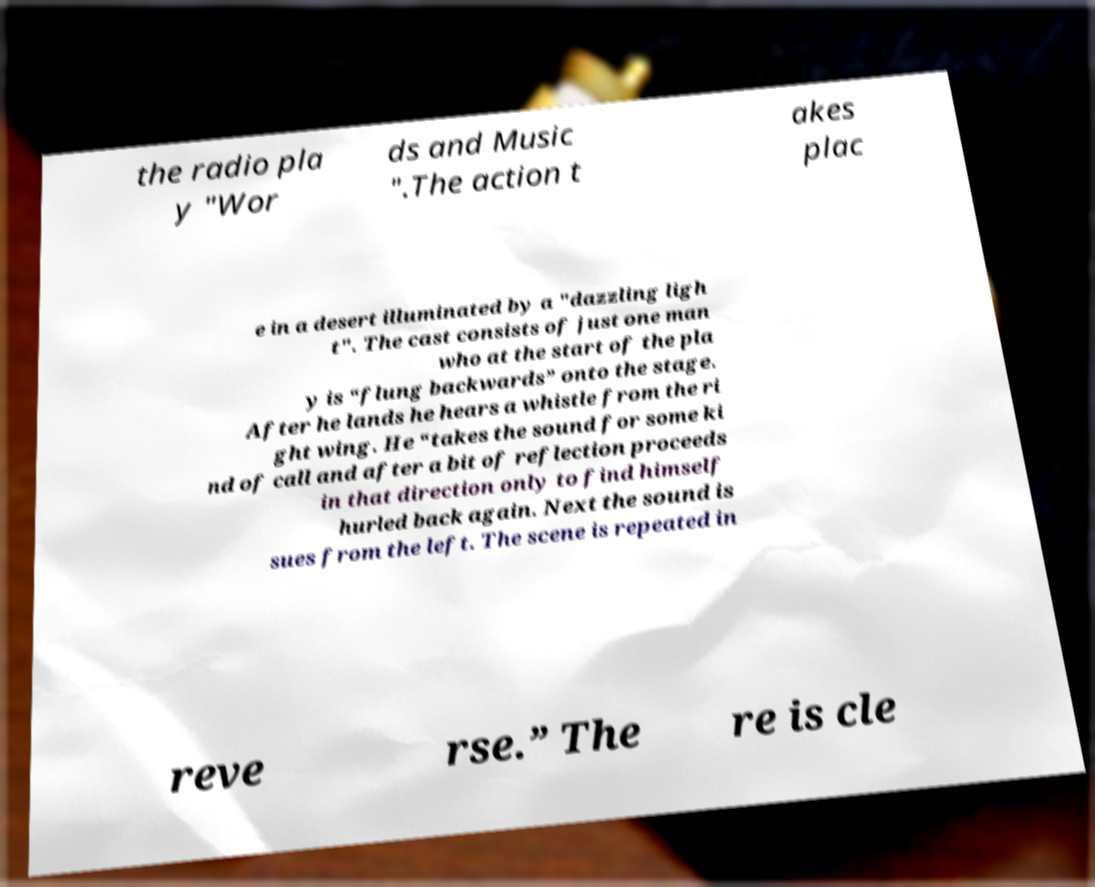Can you accurately transcribe the text from the provided image for me? the radio pla y "Wor ds and Music ".The action t akes plac e in a desert illuminated by a "dazzling ligh t". The cast consists of just one man who at the start of the pla y is “flung backwards” onto the stage. After he lands he hears a whistle from the ri ght wing. He “takes the sound for some ki nd of call and after a bit of reflection proceeds in that direction only to find himself hurled back again. Next the sound is sues from the left. The scene is repeated in reve rse.” The re is cle 